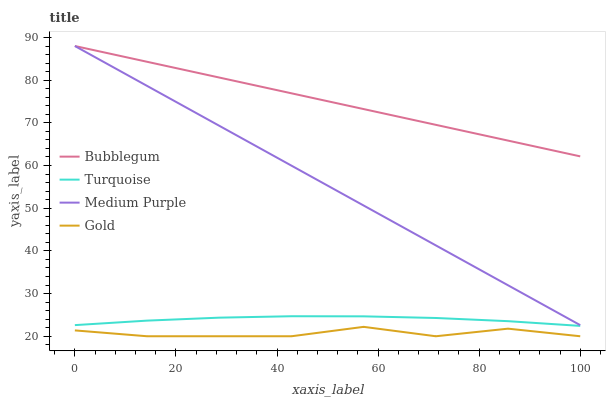Does Gold have the minimum area under the curve?
Answer yes or no. Yes. Does Bubblegum have the maximum area under the curve?
Answer yes or no. Yes. Does Turquoise have the minimum area under the curve?
Answer yes or no. No. Does Turquoise have the maximum area under the curve?
Answer yes or no. No. Is Medium Purple the smoothest?
Answer yes or no. Yes. Is Gold the roughest?
Answer yes or no. Yes. Is Turquoise the smoothest?
Answer yes or no. No. Is Turquoise the roughest?
Answer yes or no. No. Does Gold have the lowest value?
Answer yes or no. Yes. Does Turquoise have the lowest value?
Answer yes or no. No. Does Bubblegum have the highest value?
Answer yes or no. Yes. Does Turquoise have the highest value?
Answer yes or no. No. Is Turquoise less than Medium Purple?
Answer yes or no. Yes. Is Turquoise greater than Gold?
Answer yes or no. Yes. Does Bubblegum intersect Medium Purple?
Answer yes or no. Yes. Is Bubblegum less than Medium Purple?
Answer yes or no. No. Is Bubblegum greater than Medium Purple?
Answer yes or no. No. Does Turquoise intersect Medium Purple?
Answer yes or no. No. 